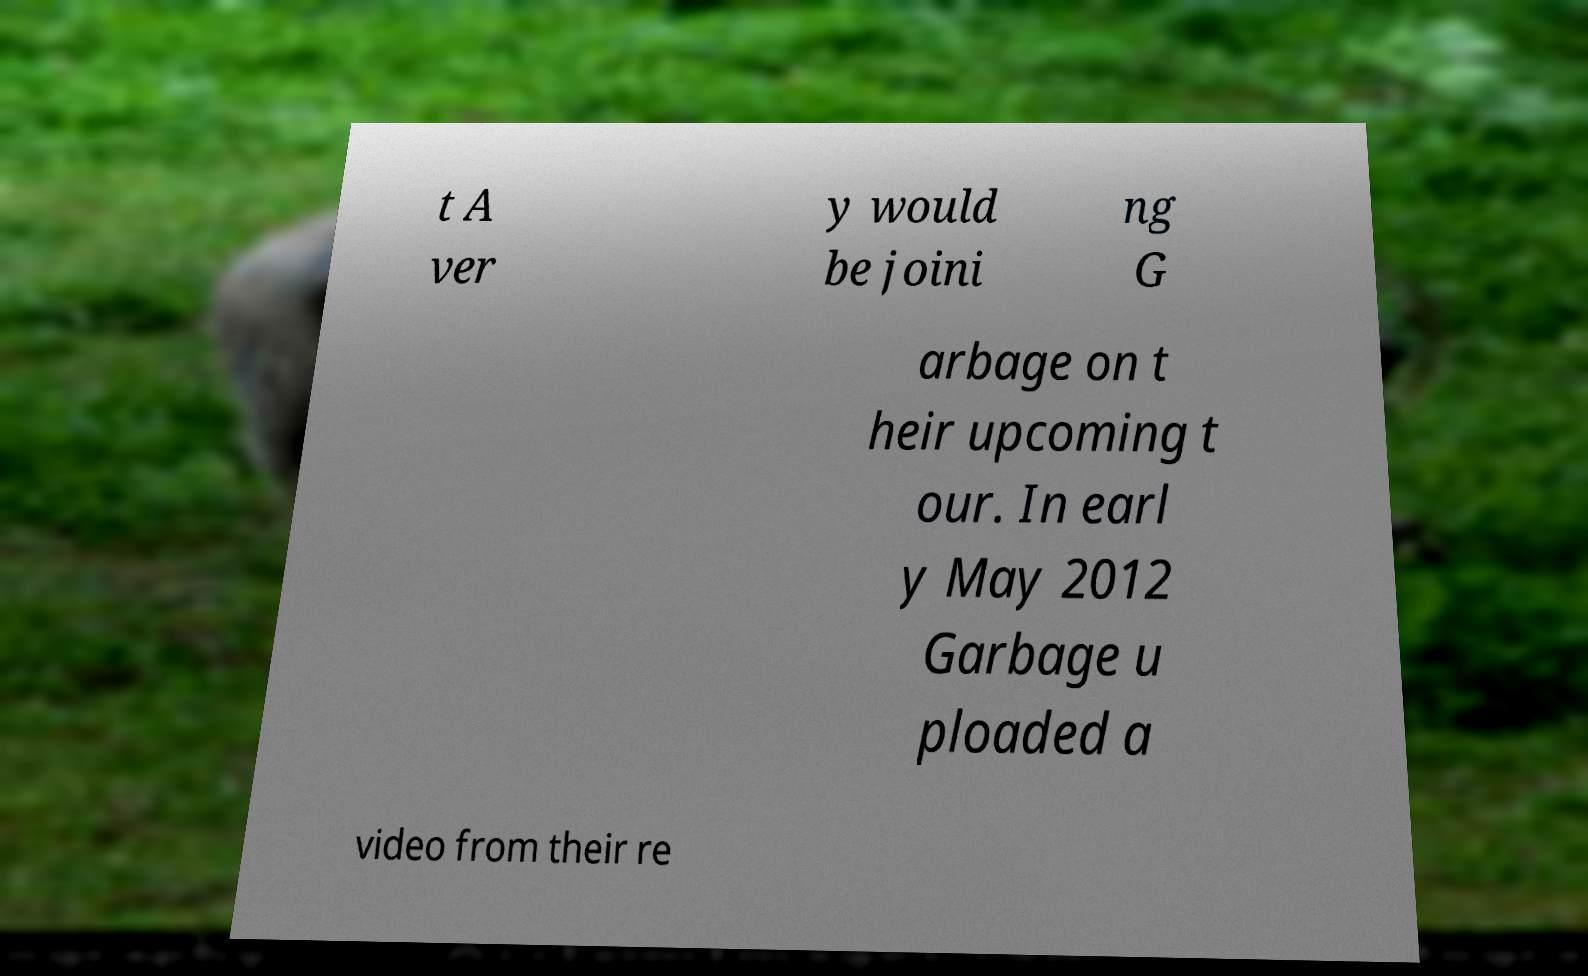Could you assist in decoding the text presented in this image and type it out clearly? t A ver y would be joini ng G arbage on t heir upcoming t our. In earl y May 2012 Garbage u ploaded a video from their re 